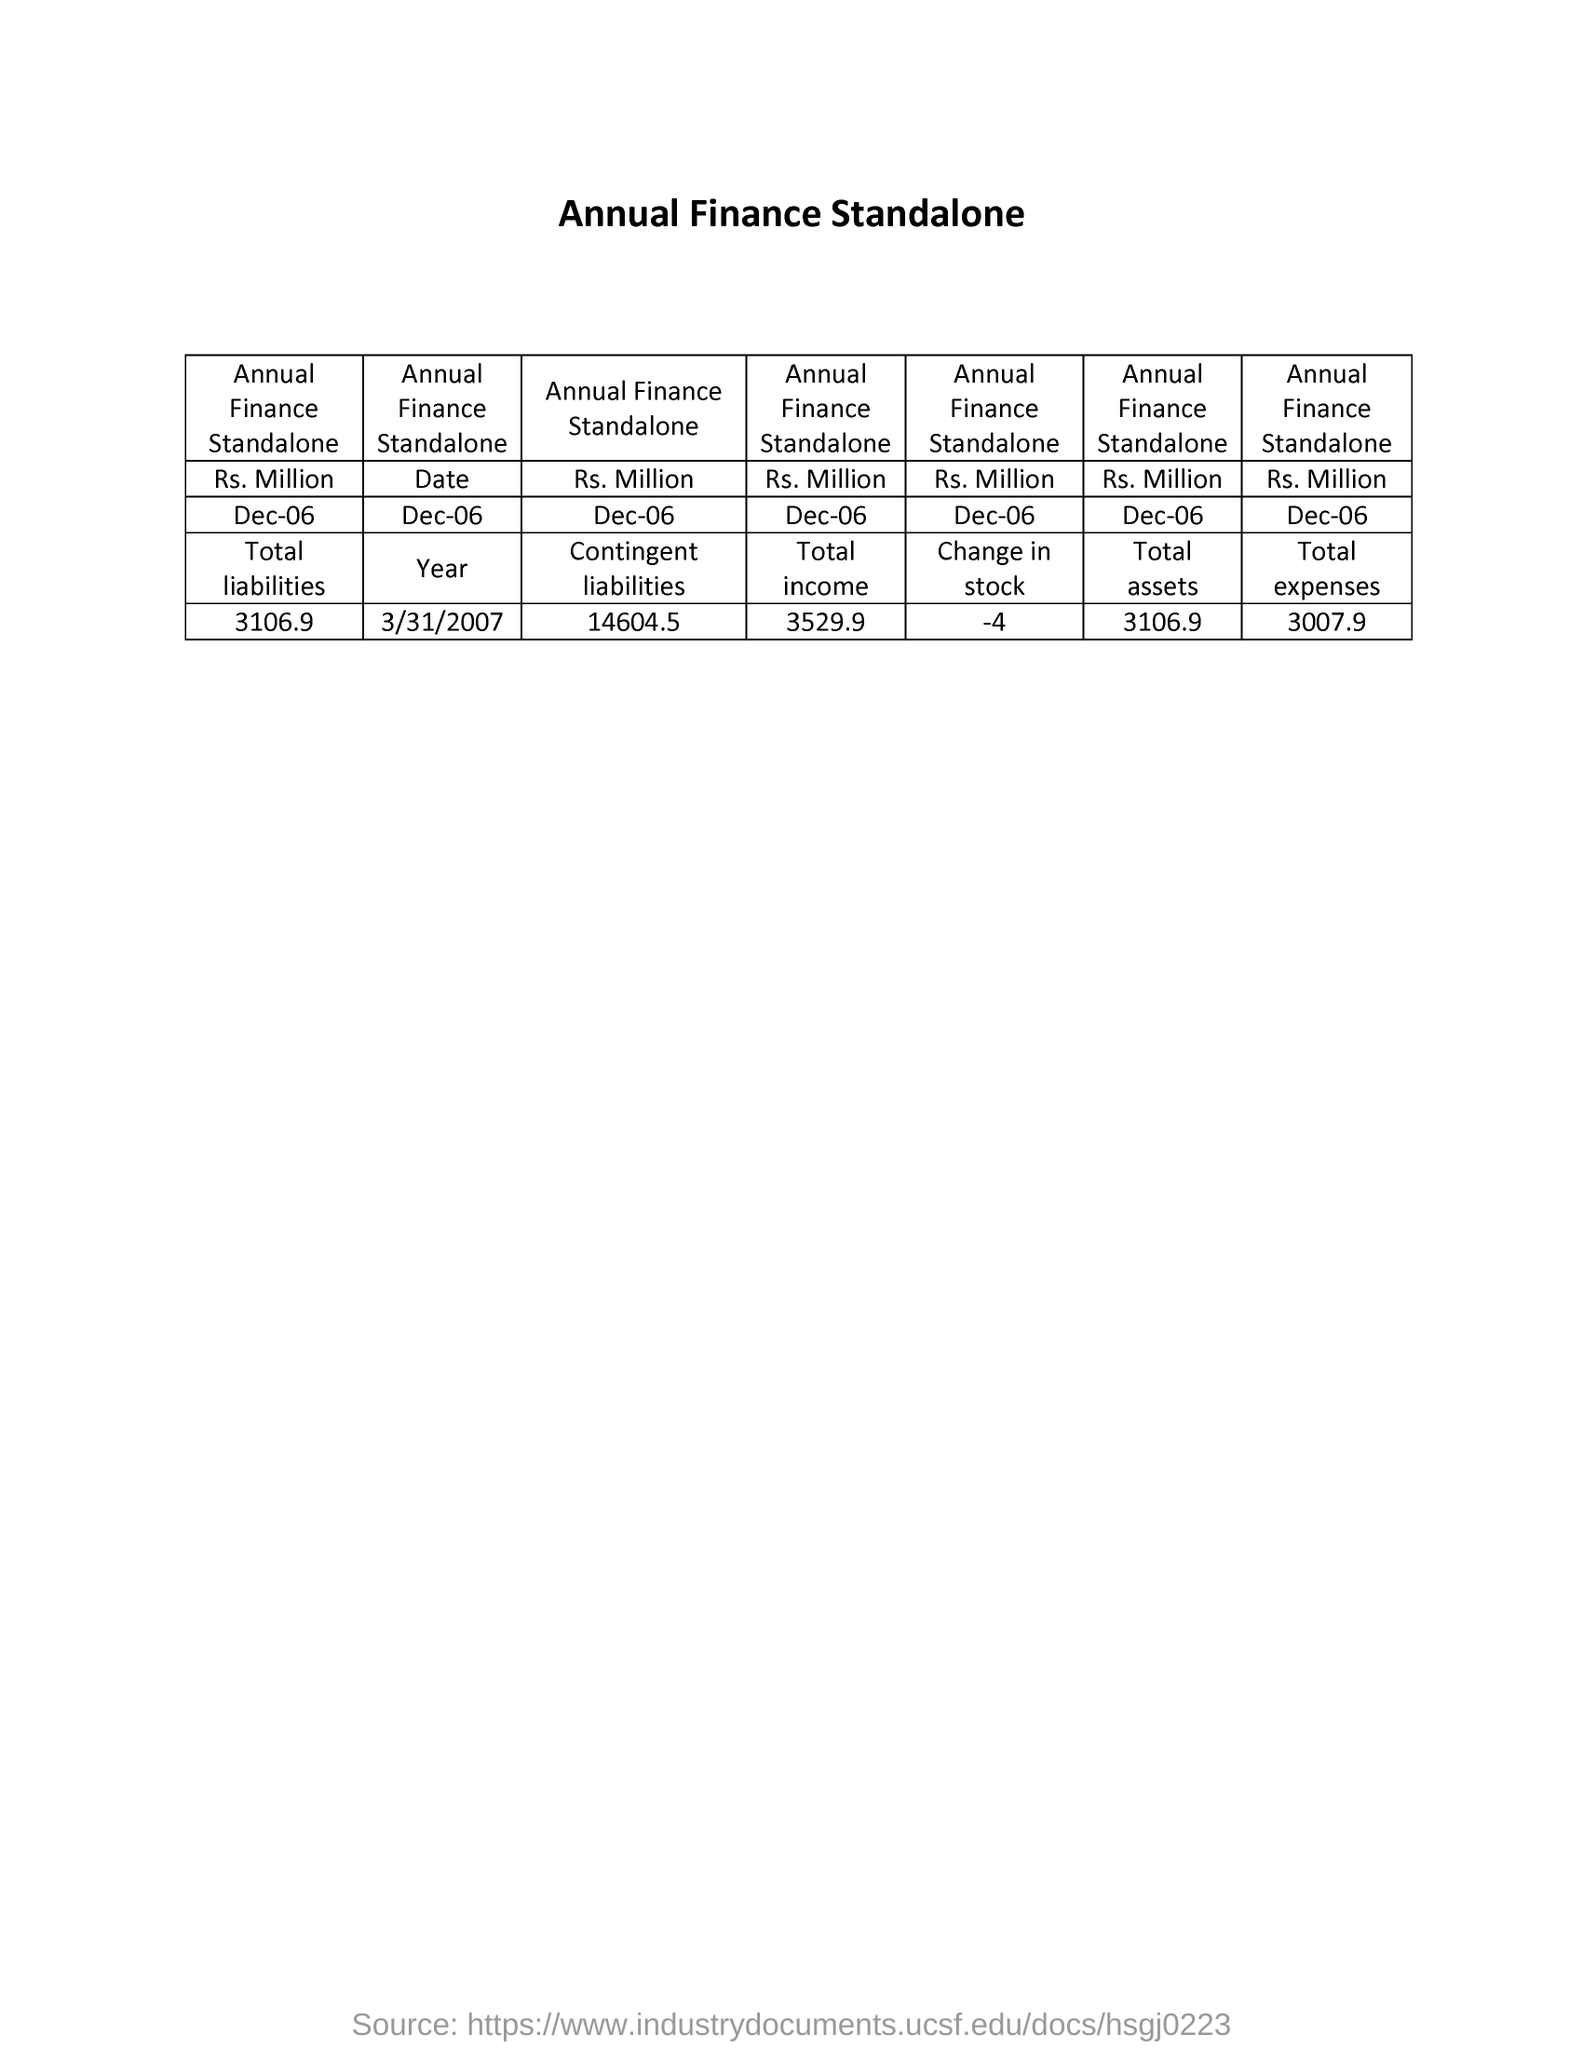What is the annual finance stand alone rs millions as on dec-06 for total liabilities?
Offer a very short reply. 3106.9. What is the annual finance stand alone dated as on dec-06 for which year ?
Offer a very short reply. 3/31/2007. What is the annual finance stand alone rs millions as on dec-06 for contingent liabilities
Your answer should be compact. 14604.5. What is the annual finance stand alone rs millions as on dec-06 for total income ?
Give a very brief answer. 3529.9. What is the annual finance stand alone rs millions as on dec-06 for change in stock
Offer a terse response. -4. What is the annual finance stand alone rs millions as on dec-06 for total assets
Provide a short and direct response. 3106.9. What is the annual finance stand alone rs millions as on dec-06 for total expenses
Your answer should be compact. 3007.9. 